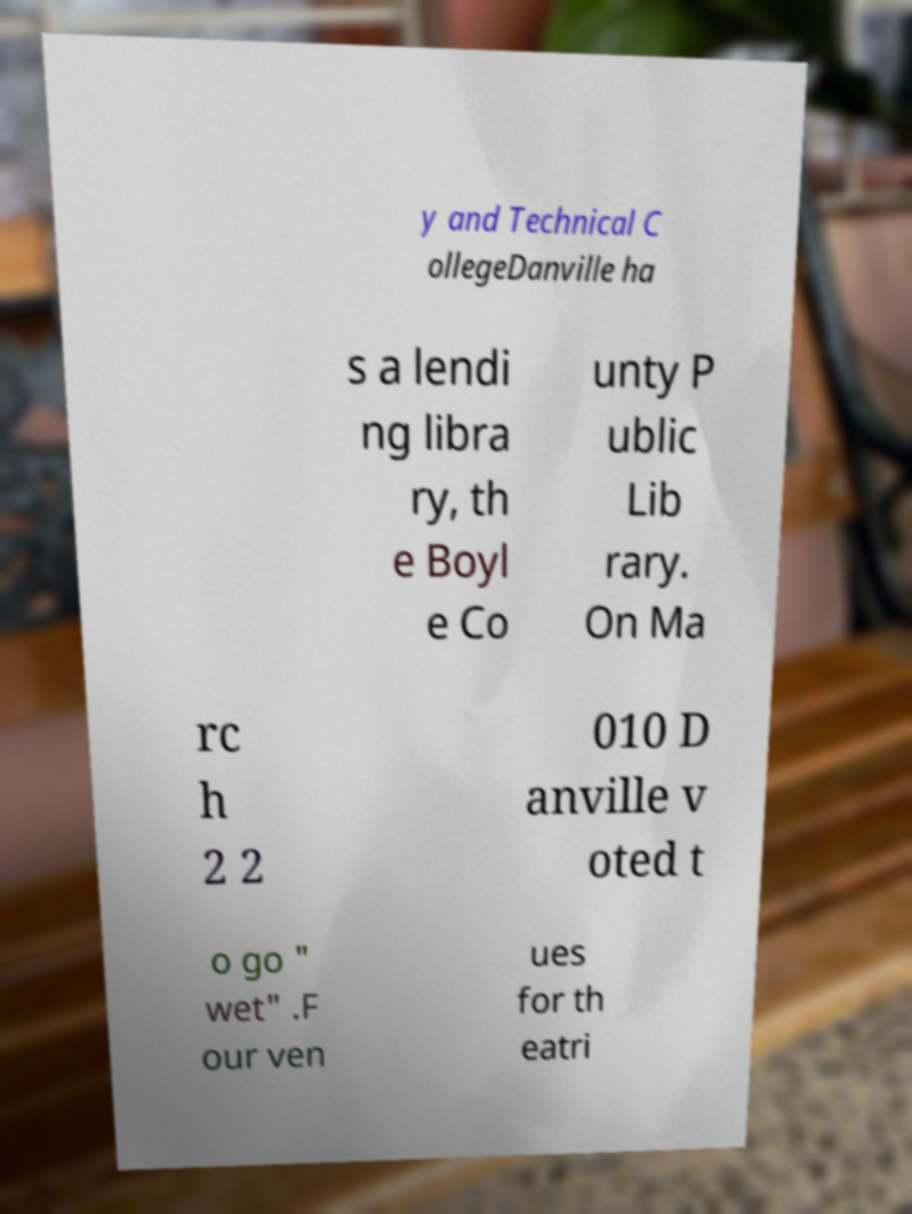Could you assist in decoding the text presented in this image and type it out clearly? y and Technical C ollegeDanville ha s a lendi ng libra ry, th e Boyl e Co unty P ublic Lib rary. On Ma rc h 2 2 010 D anville v oted t o go " wet" .F our ven ues for th eatri 